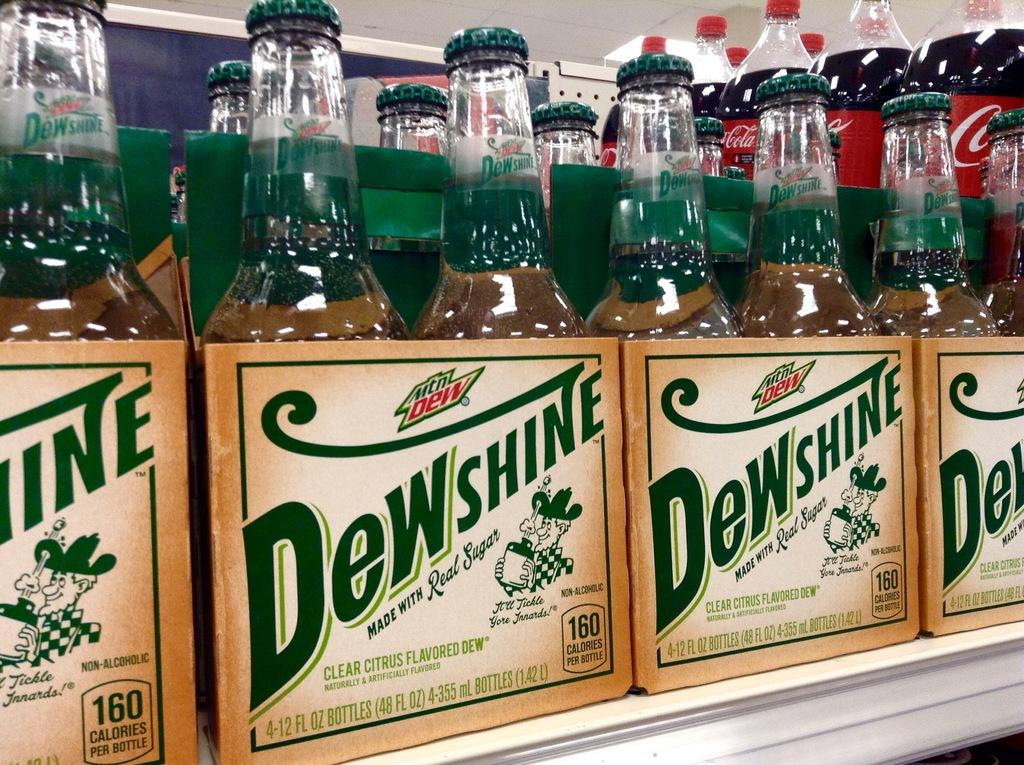<image>
Write a terse but informative summary of the picture. A shelf with Dewshine alcohol in 4 pack boxes 